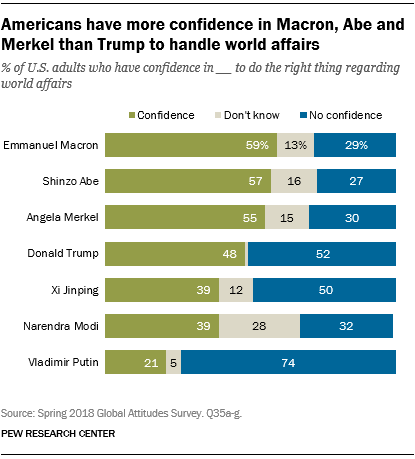Highlight a few significant elements in this photo. The total of confidence and no confidence for Vladimir Putin is 95%. The color of bars that represent "Confidence" is green. 